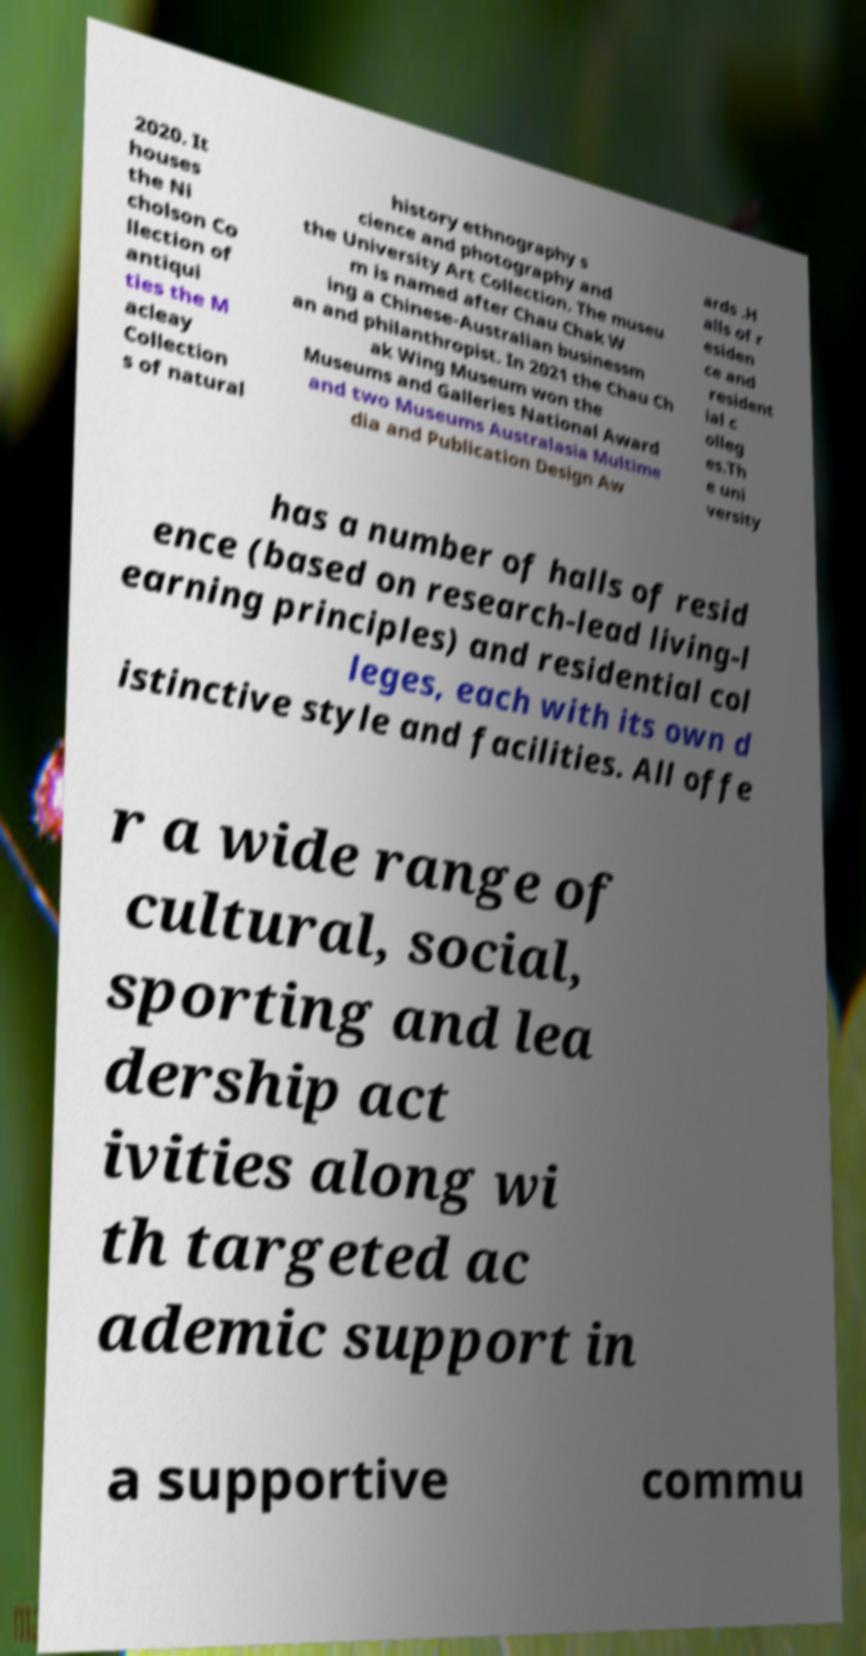Please identify and transcribe the text found in this image. 2020. It houses the Ni cholson Co llection of antiqui ties the M acleay Collection s of natural history ethnography s cience and photography and the University Art Collection. The museu m is named after Chau Chak W ing a Chinese-Australian businessm an and philanthropist. In 2021 the Chau Ch ak Wing Museum won the Museums and Galleries National Award and two Museums Australasia Multime dia and Publication Design Aw ards .H alls of r esiden ce and resident ial c olleg es.Th e uni versity has a number of halls of resid ence (based on research-lead living-l earning principles) and residential col leges, each with its own d istinctive style and facilities. All offe r a wide range of cultural, social, sporting and lea dership act ivities along wi th targeted ac ademic support in a supportive commu 